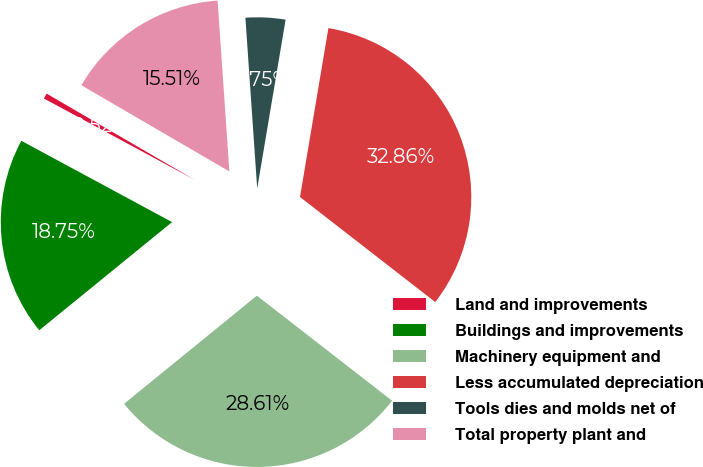<chart> <loc_0><loc_0><loc_500><loc_500><pie_chart><fcel>Land and improvements<fcel>Buildings and improvements<fcel>Machinery equipment and<fcel>Less accumulated depreciation<fcel>Tools dies and molds net of<fcel>Total property plant and<nl><fcel>0.52%<fcel>18.75%<fcel>28.61%<fcel>32.86%<fcel>3.75%<fcel>15.51%<nl></chart> 